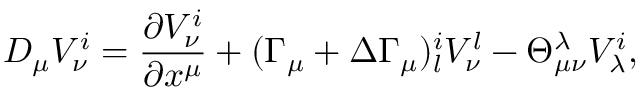<formula> <loc_0><loc_0><loc_500><loc_500>D _ { \mu } V _ { \nu } ^ { i } = \frac { \partial V _ { \nu } ^ { i } } { \partial x ^ { \mu } } + ( \Gamma _ { \mu } + \Delta \Gamma _ { \mu } ) _ { l } ^ { i } V _ { \nu } ^ { l } - \Theta _ { \mu \nu } ^ { \lambda } V _ { \lambda } ^ { i } ,</formula> 